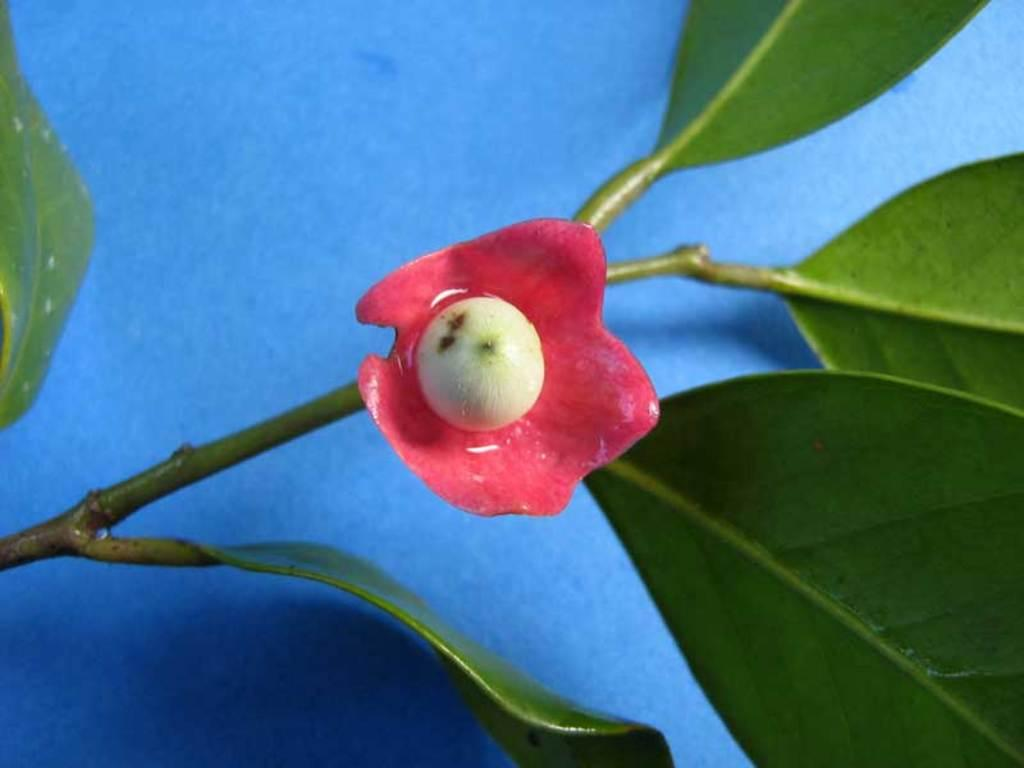What is the main subject of the image? The main subject of the image is a stem with a flower. Are there any additional features on the stem? Yes, there are leaves on the stem in the image. What color is the surface beneath the stem, flower, and leaves? The surface beneath the stem, flower, and leaves is blue. Can you see a squirrel holding a unit and a badge in the image? No, there is no squirrel, unit, or badge present in the image. 